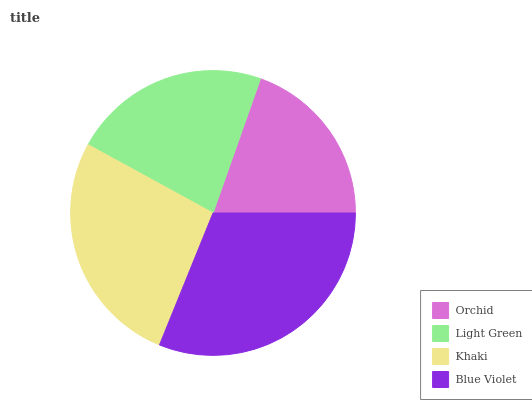Is Orchid the minimum?
Answer yes or no. Yes. Is Blue Violet the maximum?
Answer yes or no. Yes. Is Light Green the minimum?
Answer yes or no. No. Is Light Green the maximum?
Answer yes or no. No. Is Light Green greater than Orchid?
Answer yes or no. Yes. Is Orchid less than Light Green?
Answer yes or no. Yes. Is Orchid greater than Light Green?
Answer yes or no. No. Is Light Green less than Orchid?
Answer yes or no. No. Is Khaki the high median?
Answer yes or no. Yes. Is Light Green the low median?
Answer yes or no. Yes. Is Light Green the high median?
Answer yes or no. No. Is Khaki the low median?
Answer yes or no. No. 